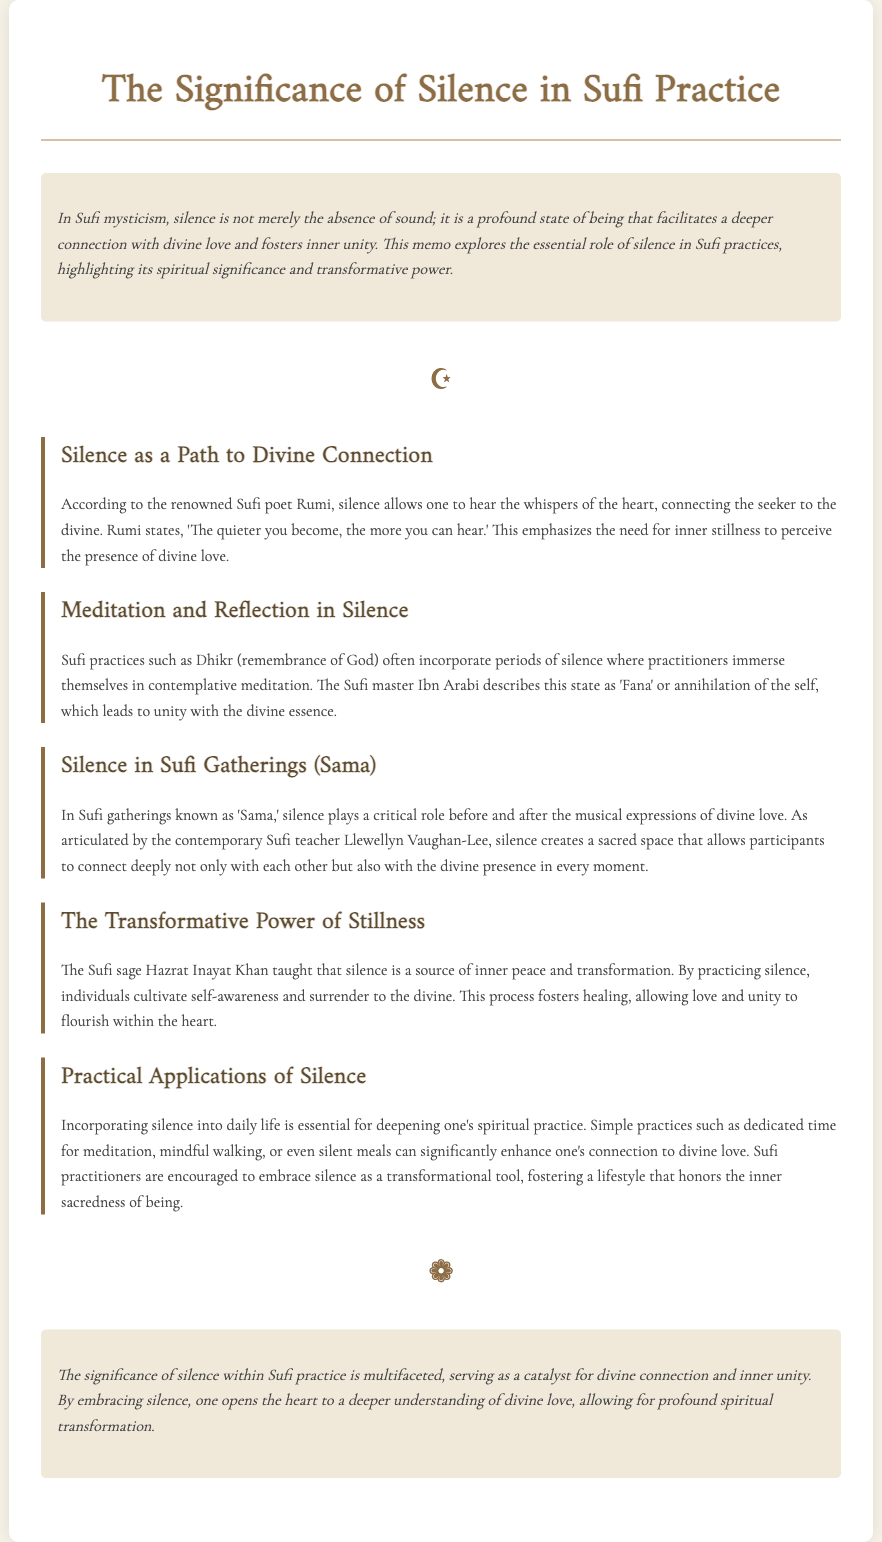What is the main theme of the document? The main theme of the document is the significance of silence in Sufi practice and its role in connecting with divine love and achieving inner unity.
Answer: Silence in Sufi practice Who quoted, "The quieter you become, the more you can hear"? This quote is attributed to the renowned Sufi poet Rumi, emphasizing the importance of silence.
Answer: Rumi What state does Ibn Arabi describe as a result of meditation in silence? Ibn Arabi describes the state of 'Fana,' which refers to the annihilation of the self leading to unity with the divine essence.
Answer: Fana According to Hazrat Inayat Khan, what does silence cultivate? Hazrat Inayat Khan states that silence cultivates self-awareness and allows individuals to surrender to the divine.
Answer: Self-awareness What is a practical application of silence mentioned in the document? The document mentions simple practices like dedicated time for meditation, mindful walking, or silent meals as practical applications of silence.
Answer: Silent meals What role does silence play in Sufi gatherings known as 'Sama'? Silence plays a critical role in creating a sacred space that enhances the connection with each other and with the divine presence in 'Sama.'
Answer: Sacred space How does the document describe the significance of silence? The document describes silence as a catalyst for divine connection and inner unity, emphasizing its transformative power.
Answer: Catalyst for divine connection 